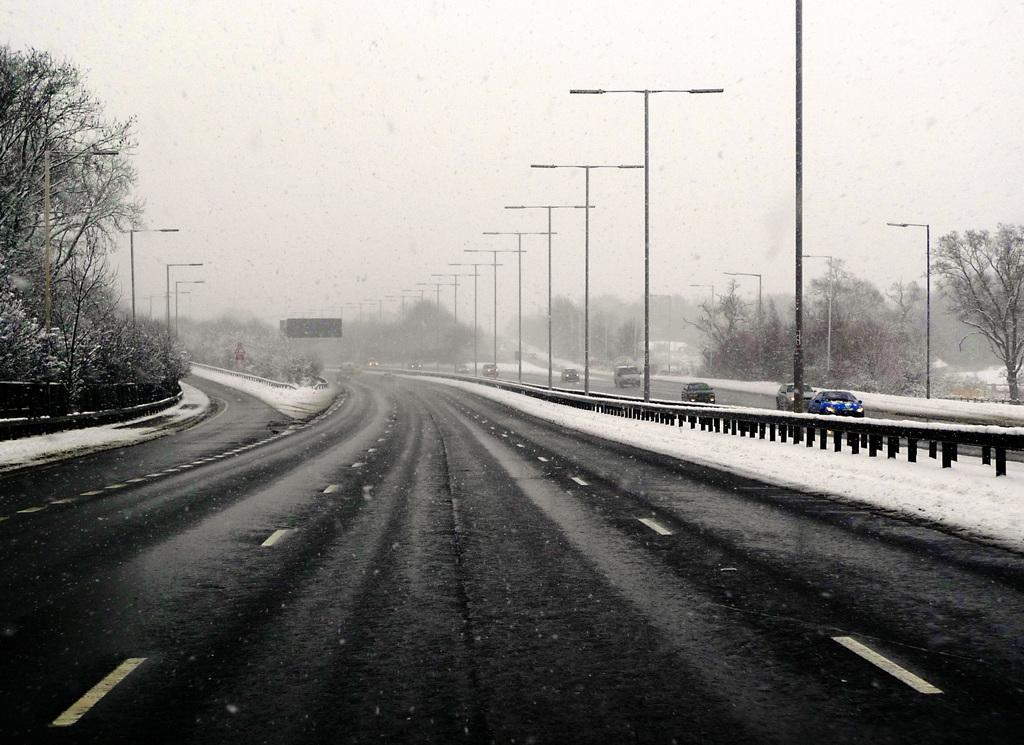What can be seen on the road in the image? There are vehicles on the road in the image. What is present on both sides of the road in the image? There are poles, trees, and boards on both sides of the road in the image. What is visible in the background of the image? The sky is visible in the background of the image. What type of club can be seen in the image? There is no club present in the image; it features vehicles on the road with poles, trees, and boards on both sides. 